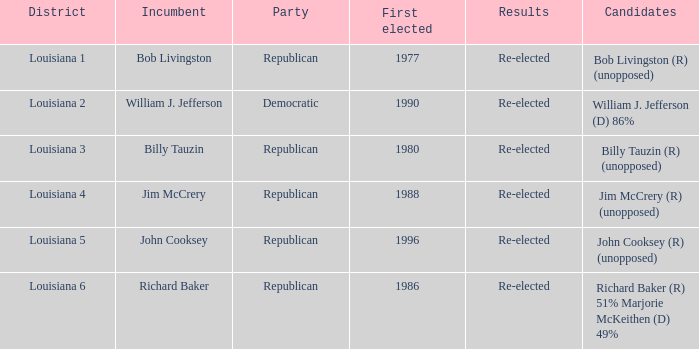How many individuals won their first election in 1980? 1.0. 